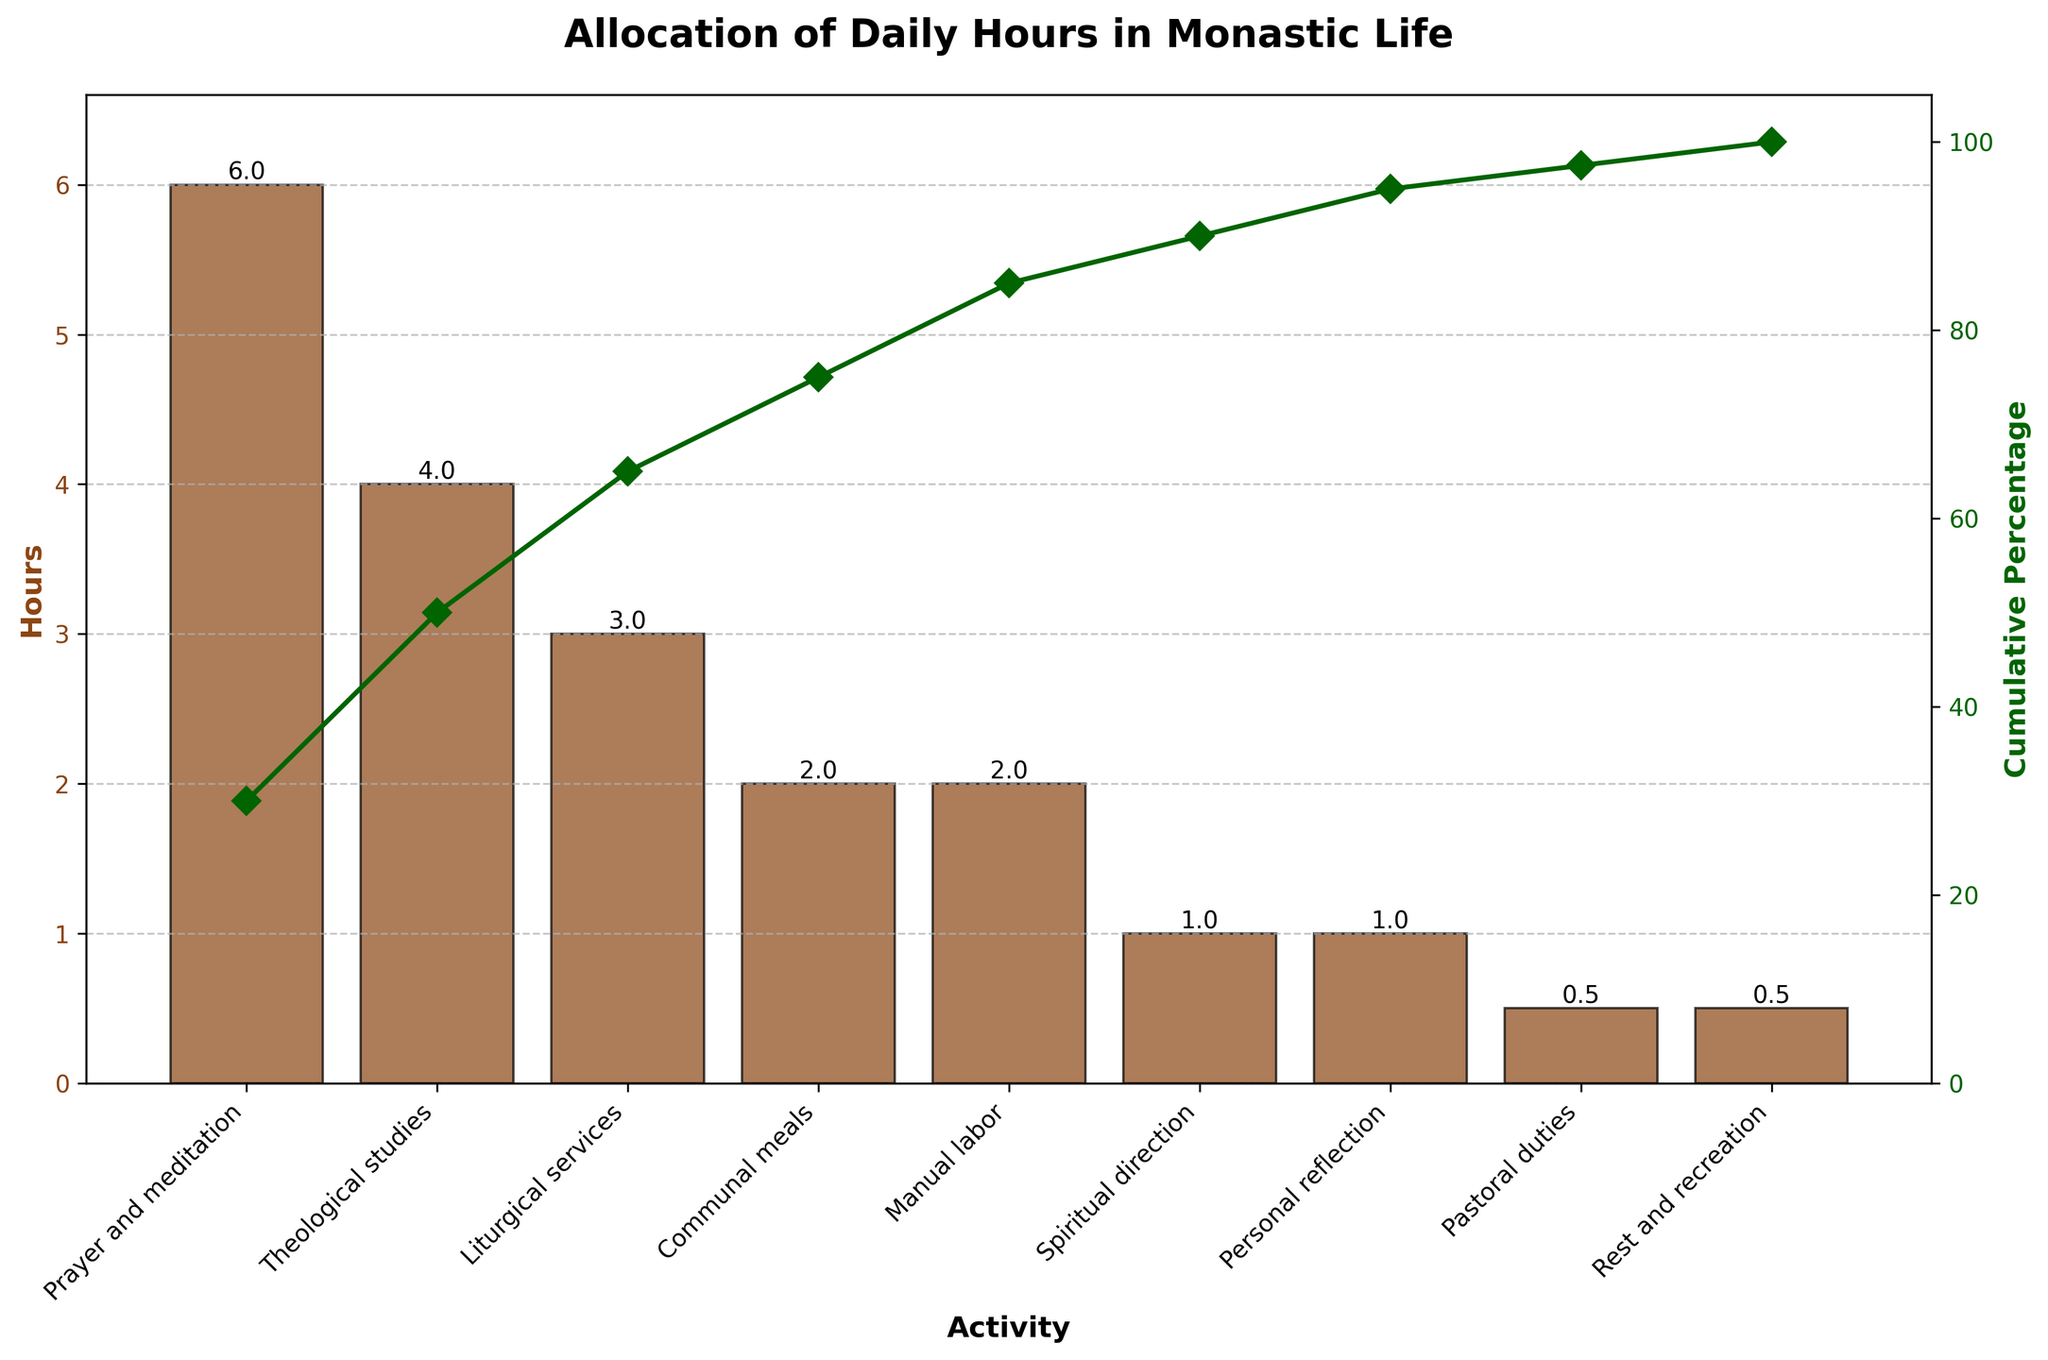What activity takes the most hours in a day? The activity taking the most hours is the one with the highest bar in the chart.
Answer: Prayer and meditation What is the cumulative percentage after "Theological studies" and "Liturgical services"? Add the hours for "Prayer and meditation", "Theological studies", and "Liturgical services" to get a cumulative value, then divide by the total hours and multiply by 100. Calculation: (6 + 4 + 3) / 20 * 100 = 65%
Answer: 65% How many activities take up 2 hours each? Locate bars showing the height of 2 hours in the chart and count them.
Answer: 2 Which activity is allocated the least amount of time daily? Find the shortest bar in the chart.
Answer: Pastoral duties and Rest and recreation What is the combined total of hours for "Communal meals" and "Manual labor"? Simply sum up the hours for these two activities. Calculation: 2 + 2 = 4
Answer: 4 hours By what percentage does "Prayer and meditation" surpass "Theological studies" in terms of hours? Subtract the hours of "Theological studies" from "Prayer and meditation", divide by the hours for "Theological studies", and then multiply by 100. Calculation: (6 - 4) / 4 * 100 = 50%
Answer: 50% What percentage of total daily hours is spent on "Manual labor"? Divide the hours of "Manual labor" by the total hours and then multiply by 100. Calculation: 2 / 20 * 100 = 10%
Answer: 10% At what cumulative percentage do we include "Communal meals"? Add up the hours for all activities up to and including "Communal meals" and then divide by total hours and multiply by 100. Calculation: (6 + 4 + 3 + 2) / 20 * 100 = 75%
Answer: 75% How do the hours for "Theological studies" compare to those for "Manual labor"? Directly compare the heights of the corresponding bars in the chart.
Answer: Greater What's the average number of hours spent on activities excluding "Prayer and meditation"? Sum up the hours of all activities excluding "Prayer and meditation" and then divide by the number of those activities. Calculation: (4 + 3 + 2 + 2 + 1 + 1 + 0.5 + 0.5) / 8 = 14 / 8 = 1.75
Answer: 1.75 hours 